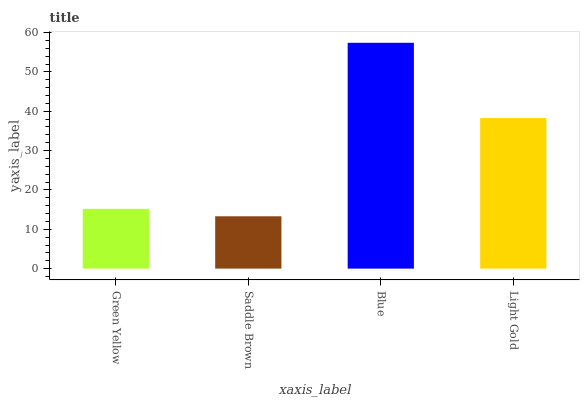Is Saddle Brown the minimum?
Answer yes or no. Yes. Is Blue the maximum?
Answer yes or no. Yes. Is Blue the minimum?
Answer yes or no. No. Is Saddle Brown the maximum?
Answer yes or no. No. Is Blue greater than Saddle Brown?
Answer yes or no. Yes. Is Saddle Brown less than Blue?
Answer yes or no. Yes. Is Saddle Brown greater than Blue?
Answer yes or no. No. Is Blue less than Saddle Brown?
Answer yes or no. No. Is Light Gold the high median?
Answer yes or no. Yes. Is Green Yellow the low median?
Answer yes or no. Yes. Is Blue the high median?
Answer yes or no. No. Is Blue the low median?
Answer yes or no. No. 